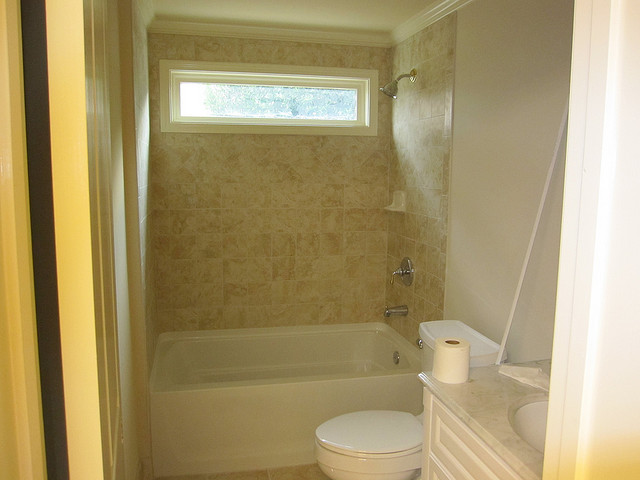How many people are wearing a hat? There are no people present in the image, hence, no one is wearing a hat. 